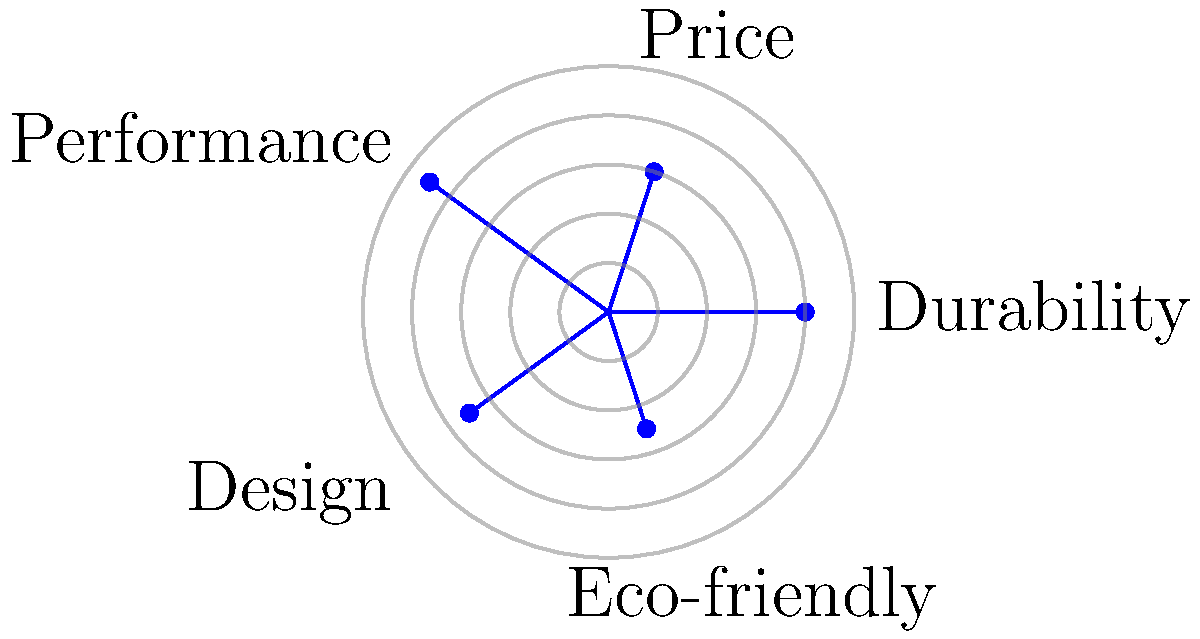In the star plot shown above, which product feature appears to be the strongest for the brand being analyzed? To determine the strongest product feature in the star plot:

1. Understand the plot:
   - Each axis represents a different product feature.
   - The distance from the center indicates the strength of that feature.

2. Identify the features:
   - Durability
   - Price
   - Performance
   - Design
   - Eco-friendly

3. Compare the lengths of each axis:
   - Durability: Extends to about 0.8
   - Price: Extends to about 0.6
   - Performance: Extends to about 0.9
   - Design: Extends to about 0.7
   - Eco-friendly: Extends to about 0.5

4. Identify the longest axis:
   - Performance has the longest axis, extending to about 0.9.

5. Interpret the result:
   - The longest axis represents the strongest feature.
   - Therefore, Performance is the strongest feature for this brand.

This analysis helps marketing executives understand product strengths, which is crucial for designing effective A/B tests and marketing strategies.
Answer: Performance 